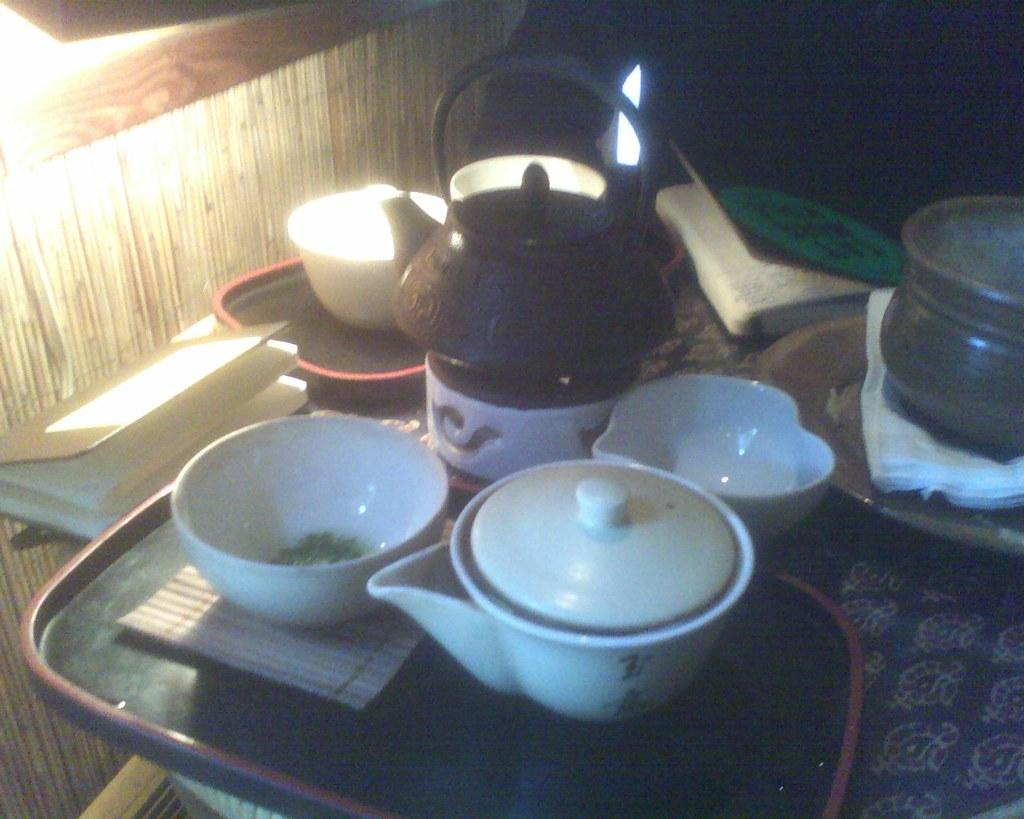What type of furniture is present in the image? There is a table in the image. What items are placed on the table? There are trays, bowls, tissues, and books on the table. Are there any other objects on the table? Yes, there are other objects on the table. What can be seen in the background of the image? There is a wall visible in the image. What is the source of illumination in the image? There are lights visible in the image. What type of engine is visible in the image? There is no engine present in the image. How does the bike support itself in the image? There is no bike present in the image, so it cannot be determined how a bike would support itself. 